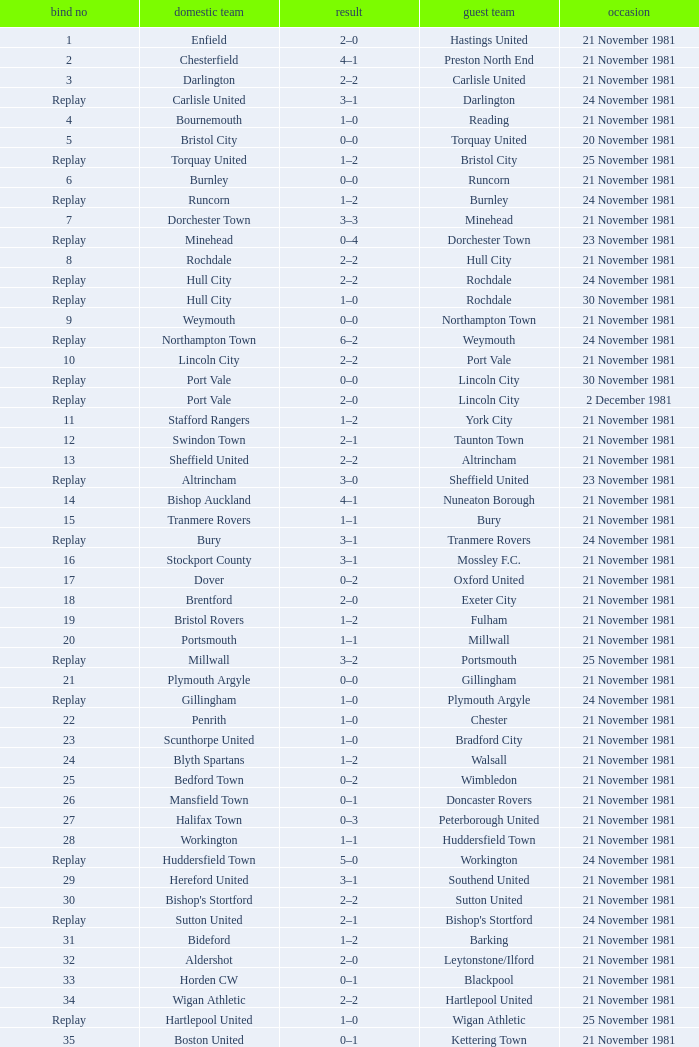On what date was tie number 4? 21 November 1981. 